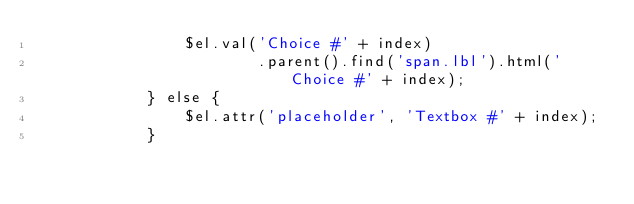<code> <loc_0><loc_0><loc_500><loc_500><_PHP_>                $el.val('Choice #' + index)
                        .parent().find('span.lbl').html('Choice #' + index);
            } else {
                $el.attr('placeholder', 'Textbox #' + index);
            }
</code> 